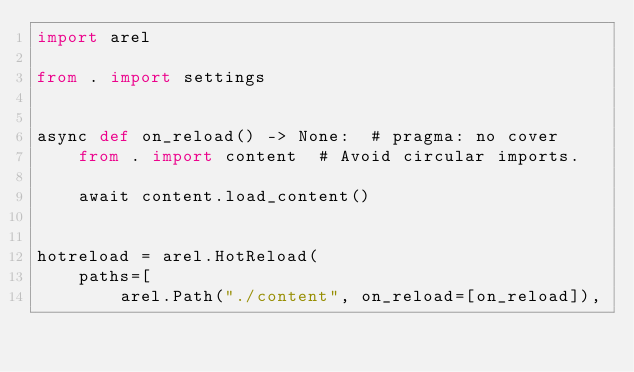Convert code to text. <code><loc_0><loc_0><loc_500><loc_500><_Python_>import arel

from . import settings


async def on_reload() -> None:  # pragma: no cover
    from . import content  # Avoid circular imports.

    await content.load_content()


hotreload = arel.HotReload(
    paths=[
        arel.Path("./content", on_reload=[on_reload]),</code> 